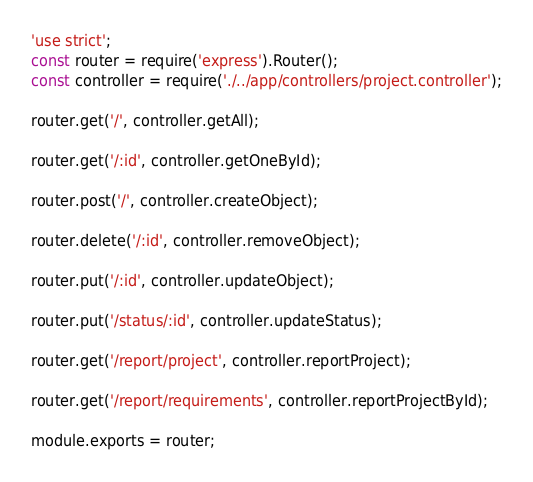<code> <loc_0><loc_0><loc_500><loc_500><_JavaScript_>'use strict';
const router = require('express').Router();
const controller = require('./../app/controllers/project.controller');

router.get('/', controller.getAll);

router.get('/:id', controller.getOneById);

router.post('/', controller.createObject);

router.delete('/:id', controller.removeObject);

router.put('/:id', controller.updateObject);

router.put('/status/:id', controller.updateStatus);

router.get('/report/project', controller.reportProject);

router.get('/report/requirements', controller.reportProjectById);

module.exports = router;
</code> 